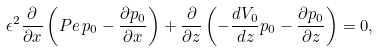<formula> <loc_0><loc_0><loc_500><loc_500>\epsilon ^ { 2 } \frac { \partial } { \partial x } \left ( P e \, p _ { 0 } - \frac { \partial p _ { 0 } } { \partial x } \right ) + \frac { \partial } { \partial z } \left ( - \frac { d V _ { 0 } } { d z } p _ { 0 } - \frac { \partial p _ { 0 } } { \partial z } \right ) = 0 ,</formula> 